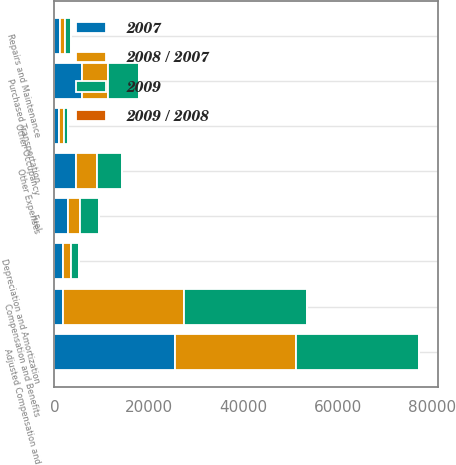Convert chart to OTSL. <chart><loc_0><loc_0><loc_500><loc_500><stacked_bar_chart><ecel><fcel>Compensation and Benefits<fcel>Adjusted Compensation and<fcel>Repairs and Maintenance<fcel>Depreciation and Amortization<fcel>Purchased Transportation<fcel>Fuel<fcel>Other Occupancy<fcel>Other Expenses<nl><fcel>2008 / 2007<fcel>25640<fcel>25640<fcel>1075<fcel>1747<fcel>5379<fcel>2365<fcel>985<fcel>4305<nl><fcel>2009<fcel>26063<fcel>26063<fcel>1194<fcel>1814<fcel>6550<fcel>4134<fcel>1027<fcel>5322<nl><fcel>2007<fcel>1747<fcel>25531<fcel>1157<fcel>1745<fcel>5902<fcel>2974<fcel>958<fcel>4633<nl><fcel>2009 / 2008<fcel>1.6<fcel>1.6<fcel>10<fcel>3.7<fcel>17.9<fcel>42.8<fcel>4.1<fcel>19.1<nl></chart> 